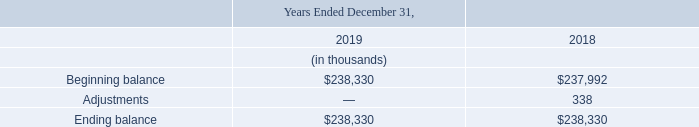Goodwill
Goodwill arises from the acquisition method of accounting for business combinations and represents the excess of the purchase price over the fair value of the net assets and other identifiable intangible assets acquired. The fair values of net tangible assets and intangible assets acquired are based upon preliminary valuations and the Company's estimates and assumptions are subject to change within the measurement period (potentially up to one year from the acquisition date).
The following table presents the changes in the carrying amount of goodwill for the periods indicated:
The Company performs an annual goodwill impairment assessment on October 31st each year, using a two-step quantitative assessment. Step one is the identification of potential impairment. This involves comparing the fair value of each reporting unit, which the Company has determined to be the entity itself, with its carrying amount, including goodwill.
If the fair value of a reporting unit exceeds the carrying amount, the goodwill of the reporting unit is considered not impaired and the second step of the impairment test is unnecessary. If the carrying amount of a reporting unit exceeds its fair value, the second step of the impairment test is performed to measure the amount of impairment loss, if any.
The Company determined there were no indications of impairment associated with goodwill. As a result,n o goodwill impairment was recognized as of October 31, 2019. In addition to its annual review, the Company performs a test of impairment when indicators of impairment are present. As of December 31, 2019, there were no indications of impairment of the Company’s goodwill balances.
How does Goodwill arise from? The acquisition method of accounting for business combinations and represents the excess of the purchase price over the fair value of the net assets and other identifiable intangible assets acquired. When does the company perform an annual goodwill impairment assessment? October 31st. What were the adjustments in 2018?
Answer scale should be: thousand. 338. What was the change in the Beginning balance from 2018 to 2019?
Answer scale should be: thousand. 238,330 - 237,992
Answer: 338. What is the average adjustments for 2018 and 2019?
Answer scale should be: thousand. (0 + 338) / 2
Answer: 169. In which year was the ending balance less than 240,000 thousands? Locate and analyze ending balance in row 6
answer: 2019, 2018. 